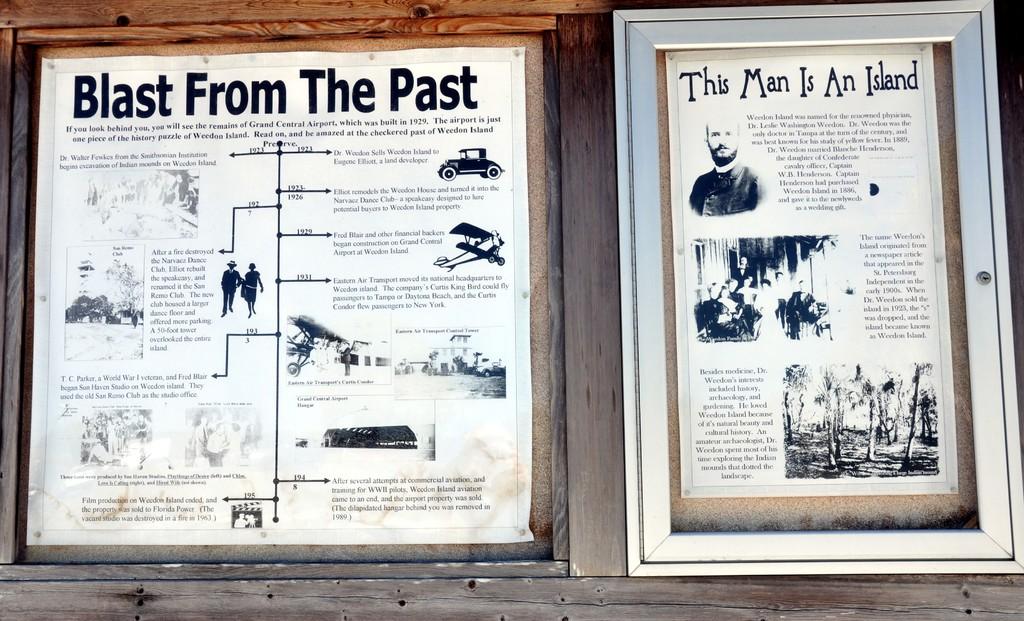What is this man in the right sign?
Ensure brevity in your answer.  An island. What is the title of the poster on the left?
Provide a succinct answer. Blast from the past. 